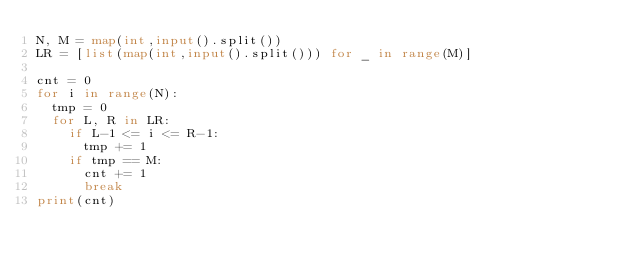Convert code to text. <code><loc_0><loc_0><loc_500><loc_500><_Python_>N, M = map(int,input().split())
LR = [list(map(int,input().split())) for _ in range(M)]

cnt = 0
for i in range(N):
  tmp = 0
  for L, R in LR:
    if L-1 <= i <= R-1:
      tmp += 1
    if tmp == M:
      cnt += 1
      break
print(cnt)</code> 